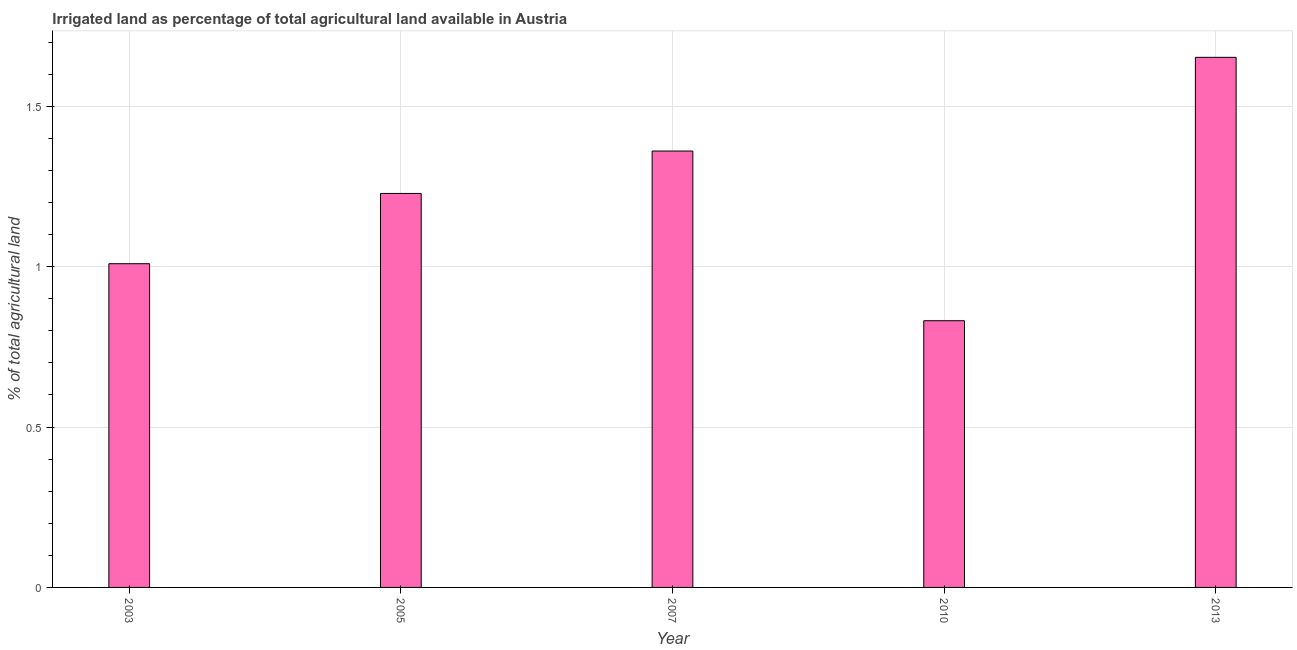What is the title of the graph?
Keep it short and to the point. Irrigated land as percentage of total agricultural land available in Austria. What is the label or title of the X-axis?
Keep it short and to the point. Year. What is the label or title of the Y-axis?
Your answer should be very brief. % of total agricultural land. What is the percentage of agricultural irrigated land in 2003?
Give a very brief answer. 1.01. Across all years, what is the maximum percentage of agricultural irrigated land?
Your response must be concise. 1.65. Across all years, what is the minimum percentage of agricultural irrigated land?
Provide a short and direct response. 0.83. In which year was the percentage of agricultural irrigated land minimum?
Offer a terse response. 2010. What is the sum of the percentage of agricultural irrigated land?
Your answer should be very brief. 6.08. What is the difference between the percentage of agricultural irrigated land in 2003 and 2005?
Give a very brief answer. -0.22. What is the average percentage of agricultural irrigated land per year?
Offer a terse response. 1.22. What is the median percentage of agricultural irrigated land?
Keep it short and to the point. 1.23. What is the ratio of the percentage of agricultural irrigated land in 2003 to that in 2007?
Keep it short and to the point. 0.74. Is the percentage of agricultural irrigated land in 2010 less than that in 2013?
Your response must be concise. Yes. What is the difference between the highest and the second highest percentage of agricultural irrigated land?
Your answer should be very brief. 0.29. Is the sum of the percentage of agricultural irrigated land in 2005 and 2007 greater than the maximum percentage of agricultural irrigated land across all years?
Your answer should be compact. Yes. What is the difference between the highest and the lowest percentage of agricultural irrigated land?
Provide a succinct answer. 0.82. Are all the bars in the graph horizontal?
Keep it short and to the point. No. What is the difference between two consecutive major ticks on the Y-axis?
Offer a very short reply. 0.5. Are the values on the major ticks of Y-axis written in scientific E-notation?
Give a very brief answer. No. What is the % of total agricultural land of 2003?
Your answer should be compact. 1.01. What is the % of total agricultural land in 2005?
Make the answer very short. 1.23. What is the % of total agricultural land in 2007?
Offer a very short reply. 1.36. What is the % of total agricultural land in 2010?
Ensure brevity in your answer.  0.83. What is the % of total agricultural land in 2013?
Keep it short and to the point. 1.65. What is the difference between the % of total agricultural land in 2003 and 2005?
Your answer should be very brief. -0.22. What is the difference between the % of total agricultural land in 2003 and 2007?
Offer a terse response. -0.35. What is the difference between the % of total agricultural land in 2003 and 2010?
Provide a short and direct response. 0.18. What is the difference between the % of total agricultural land in 2003 and 2013?
Provide a short and direct response. -0.64. What is the difference between the % of total agricultural land in 2005 and 2007?
Keep it short and to the point. -0.13. What is the difference between the % of total agricultural land in 2005 and 2010?
Offer a terse response. 0.4. What is the difference between the % of total agricultural land in 2005 and 2013?
Provide a short and direct response. -0.42. What is the difference between the % of total agricultural land in 2007 and 2010?
Your response must be concise. 0.53. What is the difference between the % of total agricultural land in 2007 and 2013?
Offer a very short reply. -0.29. What is the difference between the % of total agricultural land in 2010 and 2013?
Your answer should be compact. -0.82. What is the ratio of the % of total agricultural land in 2003 to that in 2005?
Offer a very short reply. 0.82. What is the ratio of the % of total agricultural land in 2003 to that in 2007?
Make the answer very short. 0.74. What is the ratio of the % of total agricultural land in 2003 to that in 2010?
Your answer should be compact. 1.21. What is the ratio of the % of total agricultural land in 2003 to that in 2013?
Make the answer very short. 0.61. What is the ratio of the % of total agricultural land in 2005 to that in 2007?
Keep it short and to the point. 0.9. What is the ratio of the % of total agricultural land in 2005 to that in 2010?
Provide a short and direct response. 1.48. What is the ratio of the % of total agricultural land in 2005 to that in 2013?
Provide a short and direct response. 0.74. What is the ratio of the % of total agricultural land in 2007 to that in 2010?
Make the answer very short. 1.64. What is the ratio of the % of total agricultural land in 2007 to that in 2013?
Keep it short and to the point. 0.82. What is the ratio of the % of total agricultural land in 2010 to that in 2013?
Keep it short and to the point. 0.5. 